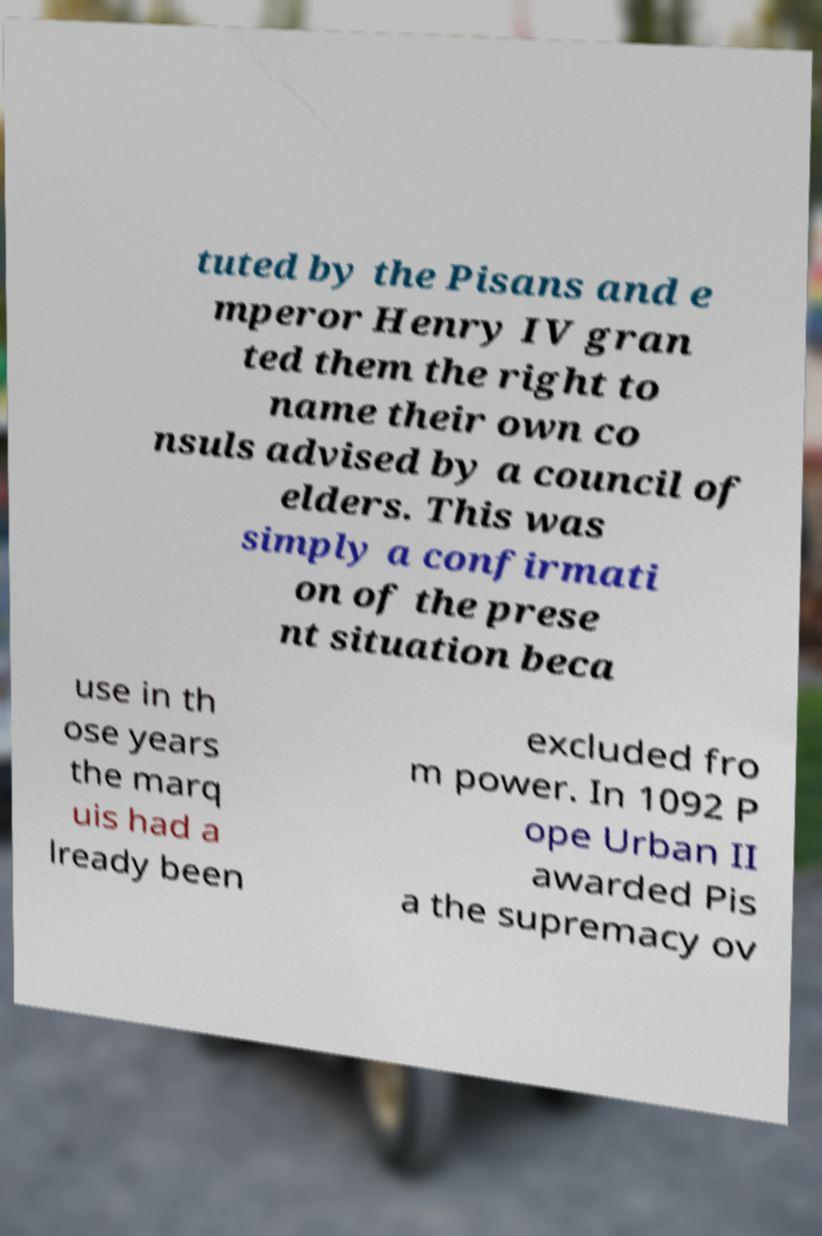For documentation purposes, I need the text within this image transcribed. Could you provide that? tuted by the Pisans and e mperor Henry IV gran ted them the right to name their own co nsuls advised by a council of elders. This was simply a confirmati on of the prese nt situation beca use in th ose years the marq uis had a lready been excluded fro m power. In 1092 P ope Urban II awarded Pis a the supremacy ov 